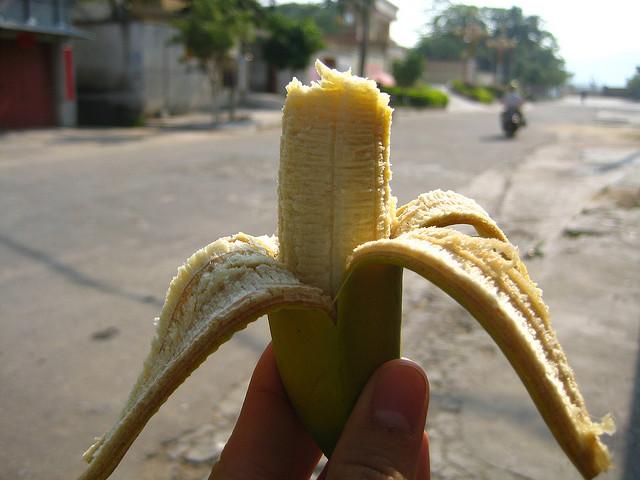What type of vehicle in the distance?
Short answer required. Motorcycle. Is the banana whole?
Answer briefly. No. What fruit is being consumed?
Be succinct. Banana. 